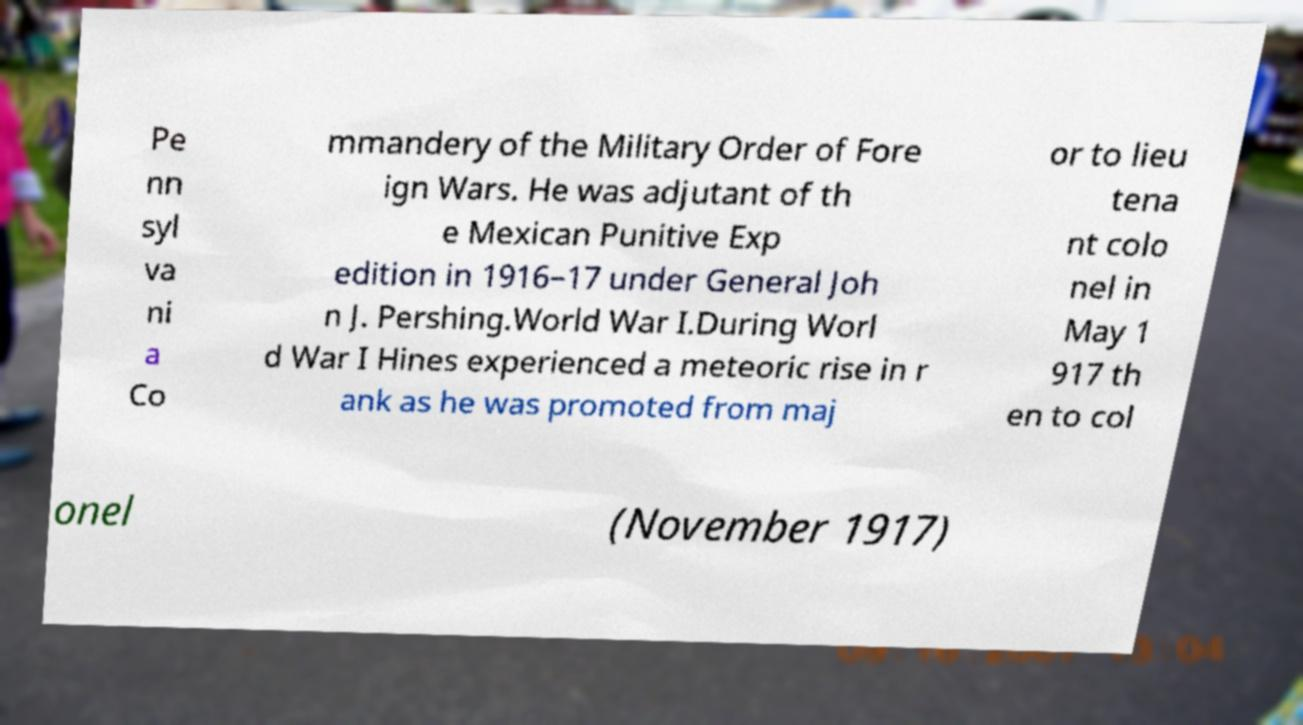Could you assist in decoding the text presented in this image and type it out clearly? Pe nn syl va ni a Co mmandery of the Military Order of Fore ign Wars. He was adjutant of th e Mexican Punitive Exp edition in 1916–17 under General Joh n J. Pershing.World War I.During Worl d War I Hines experienced a meteoric rise in r ank as he was promoted from maj or to lieu tena nt colo nel in May 1 917 th en to col onel (November 1917) 